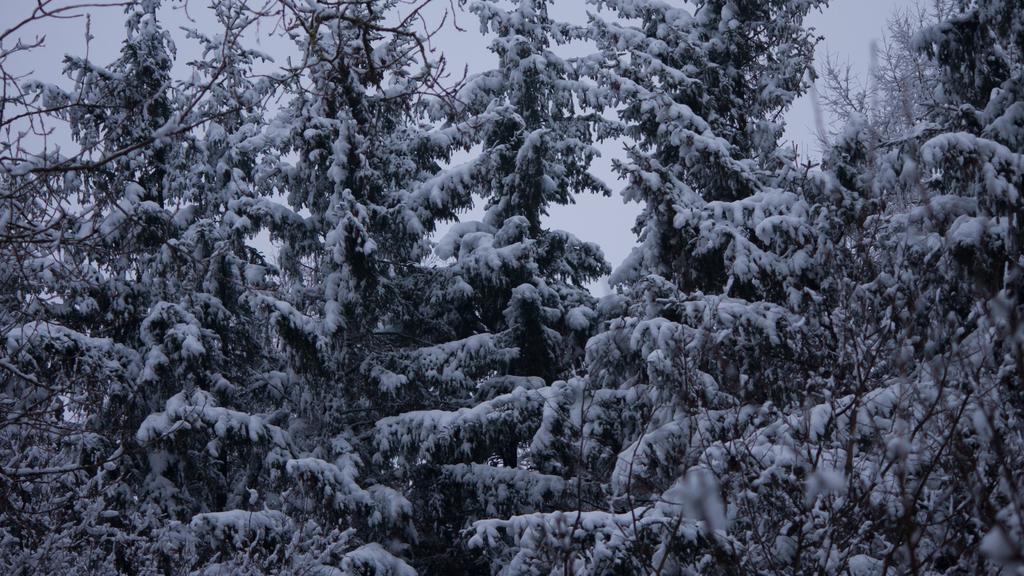How would you summarize this image in a sentence or two? This picture is a black and white image. In this image we can see some trees with snow and in the background there is the sky. 